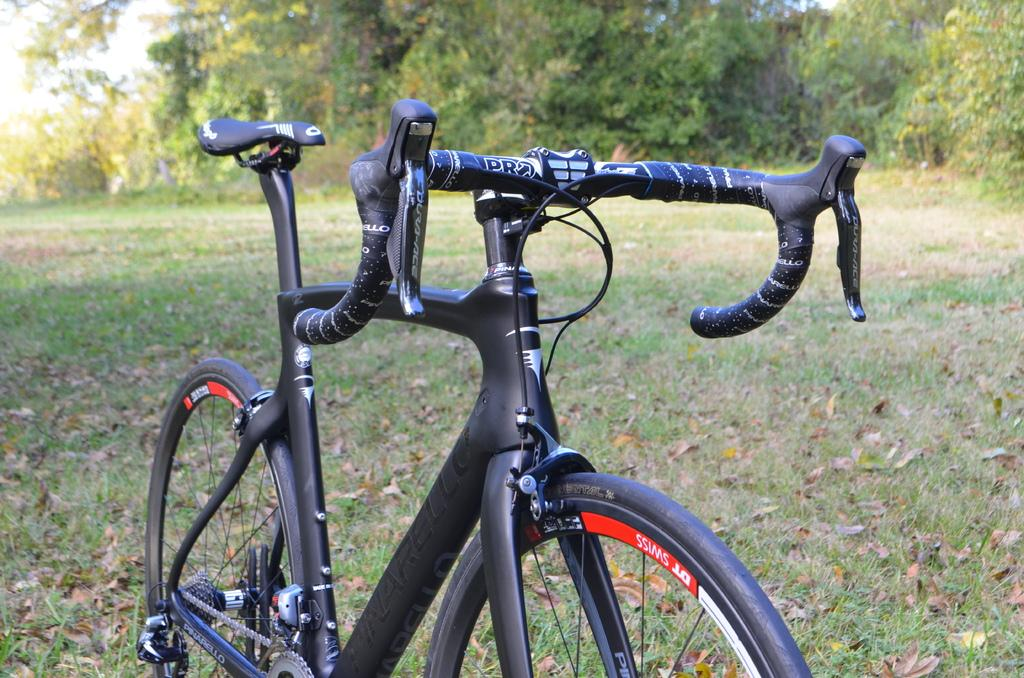What type of vehicle is in the image? There is a black cycle in the image. What can be seen on the cycle? Something is written on the cycle. What is the natural setting in the image? There is grass visible in the image. What can be seen in the background of the image? There are trees in the background of the image. How far away is the bottle from the cycle in the image? There is no bottle present in the image, so it cannot be determined how far away it might be from the cycle. 